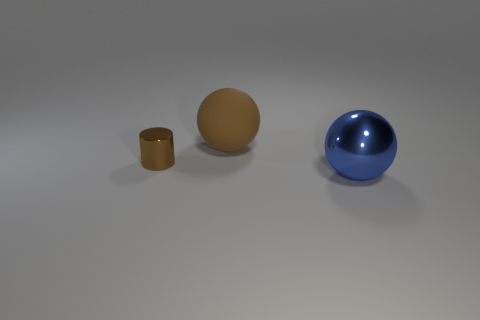Are there any other things that are the same material as the large brown sphere?
Your answer should be compact. No. There is a blue sphere that is made of the same material as the tiny brown cylinder; what is its size?
Make the answer very short. Large. Are there any small objects that have the same color as the big rubber object?
Offer a terse response. Yes. Does the cylinder have the same size as the ball that is behind the blue metallic ball?
Make the answer very short. No. What number of tiny cylinders are behind the brown metallic thing that is in front of the large object that is behind the blue shiny thing?
Your response must be concise. 0. What size is the rubber object that is the same color as the metallic cylinder?
Your answer should be very brief. Large. Are there any big objects in front of the rubber ball?
Provide a succinct answer. Yes. What is the shape of the tiny metal thing?
Keep it short and to the point. Cylinder. What is the shape of the large thing behind the metal object to the right of the brown object that is on the left side of the brown matte sphere?
Your answer should be compact. Sphere. What number of other objects are the same shape as the tiny object?
Your answer should be very brief. 0. 